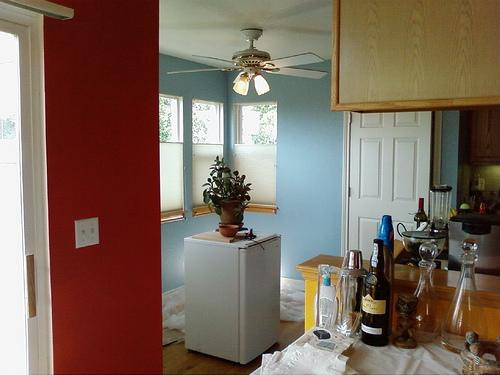What is the plant sitting on?

Choices:
A) table
B) trunk
C) microwave
D) refrigerator refrigerator 